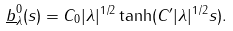Convert formula to latex. <formula><loc_0><loc_0><loc_500><loc_500>\underline { b } ^ { 0 } _ { \lambda } ( s ) = C _ { 0 } | \lambda | ^ { 1 / 2 } \tanh ( C ^ { \prime } | \lambda | ^ { 1 / 2 } s ) .</formula> 